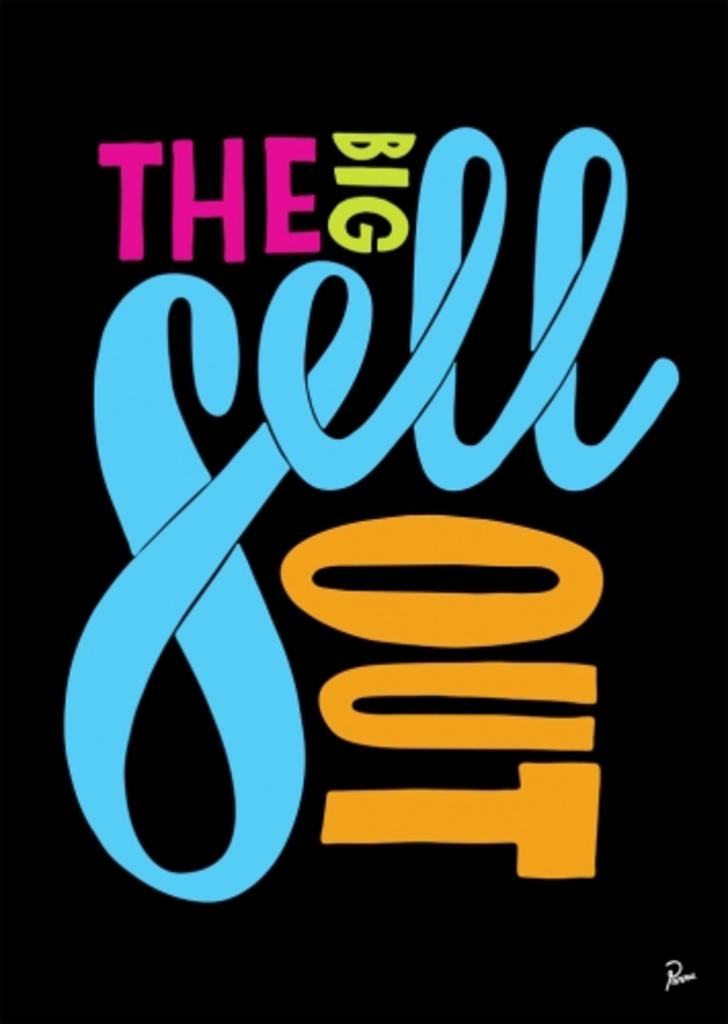<image>
Render a clear and concise summary of the photo. A black poster with words in pink, green, blue, and orange, and the blue word is sell. 